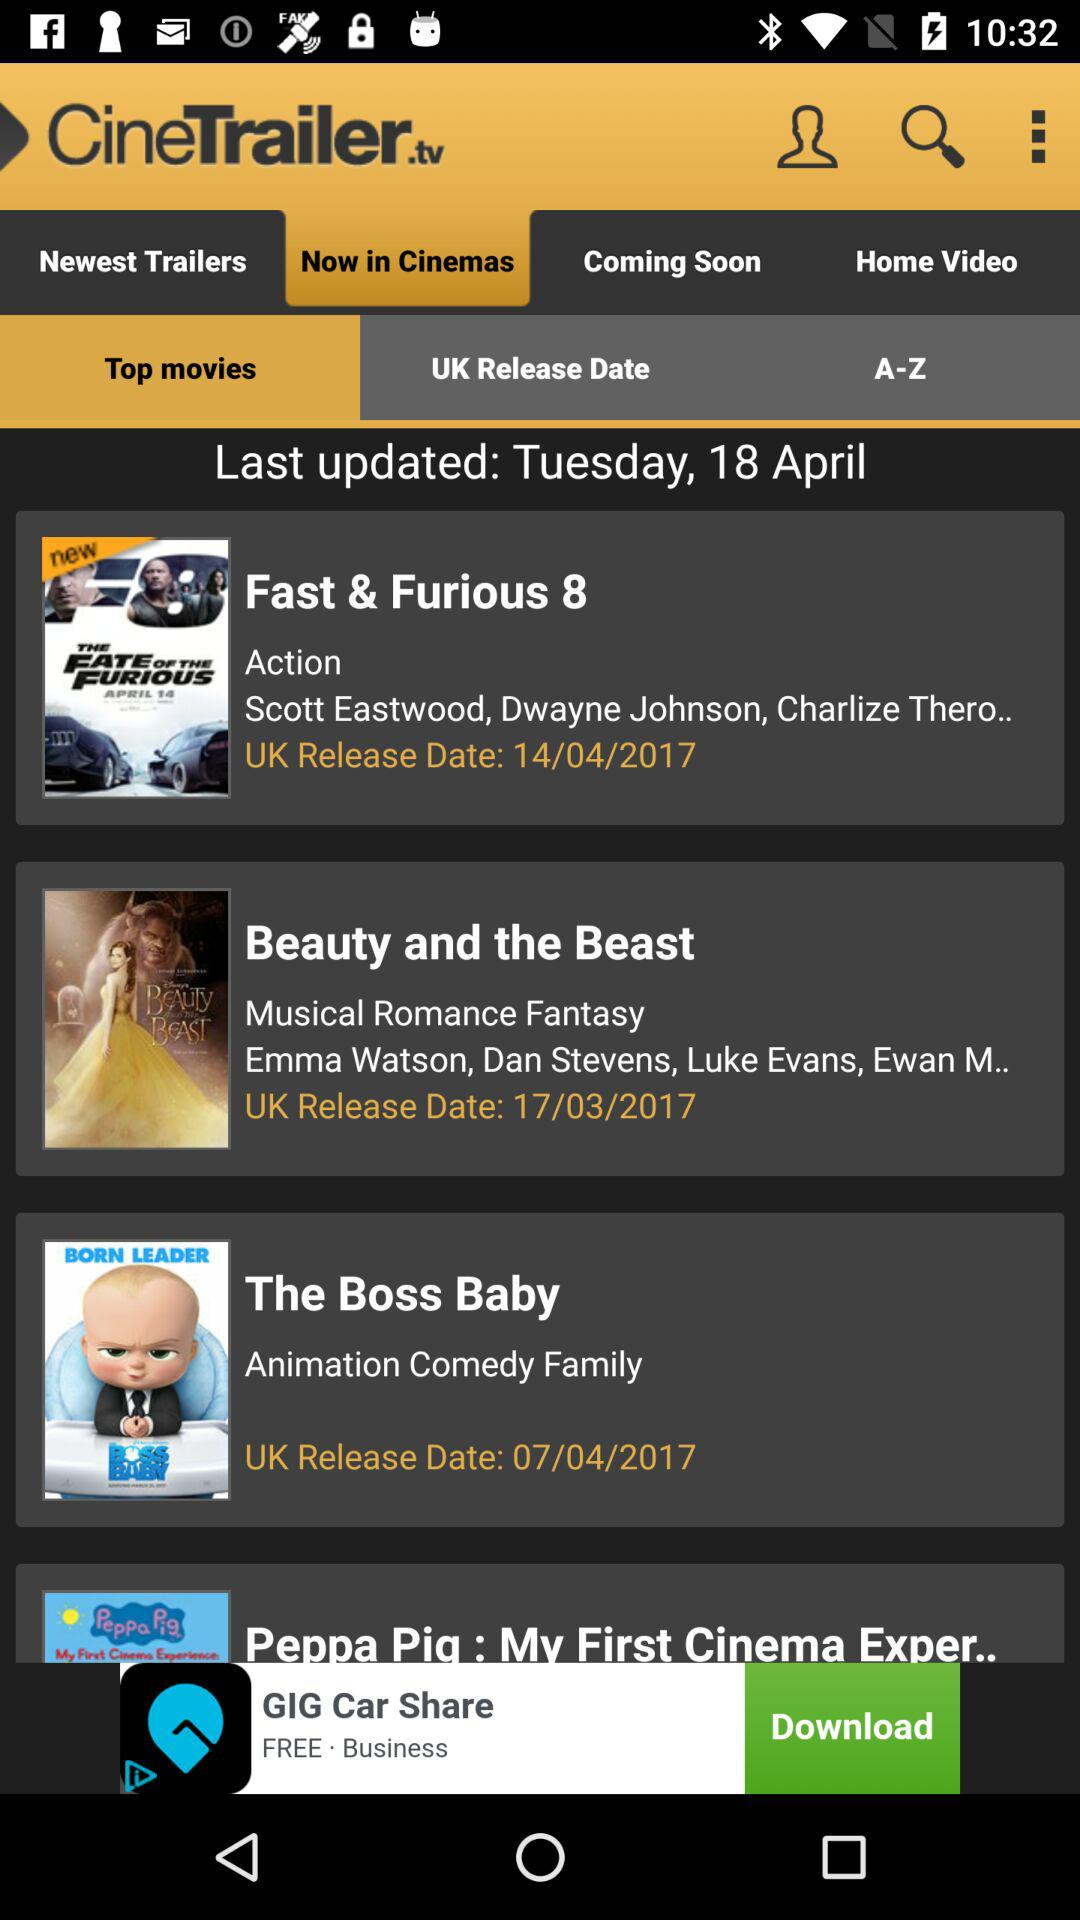What is the release date of "The Boss Baby"? The release date of "The Boss Baby" is April 7, 2017. 